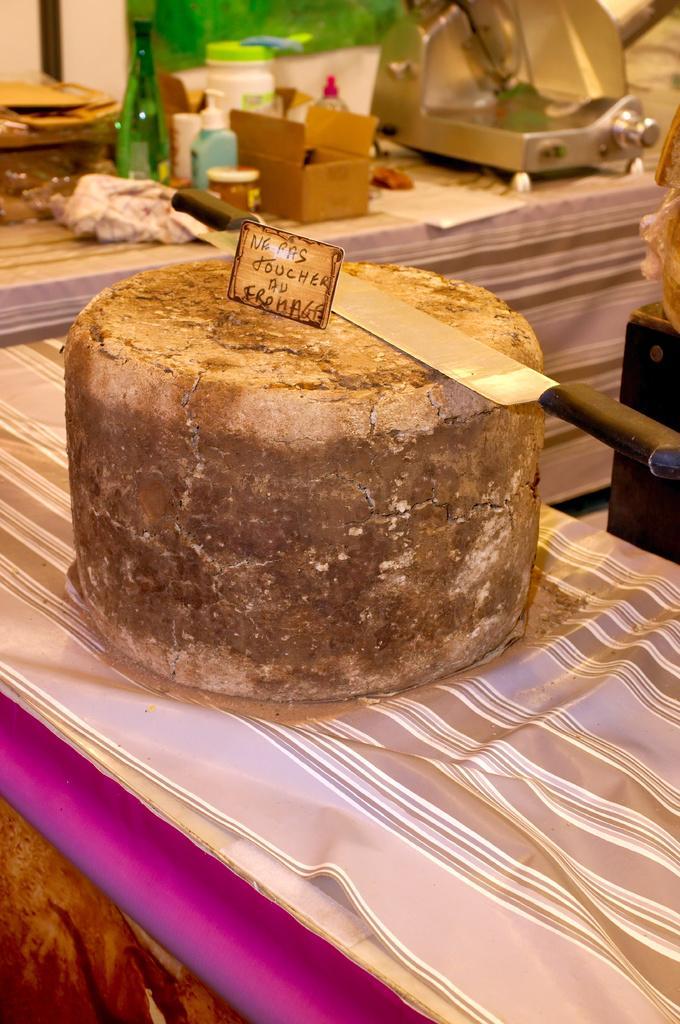In one or two sentences, can you explain what this image depicts? In this image I can see a knife and a board on an object, there is a bottle, container and other objects at the back. at the back. 